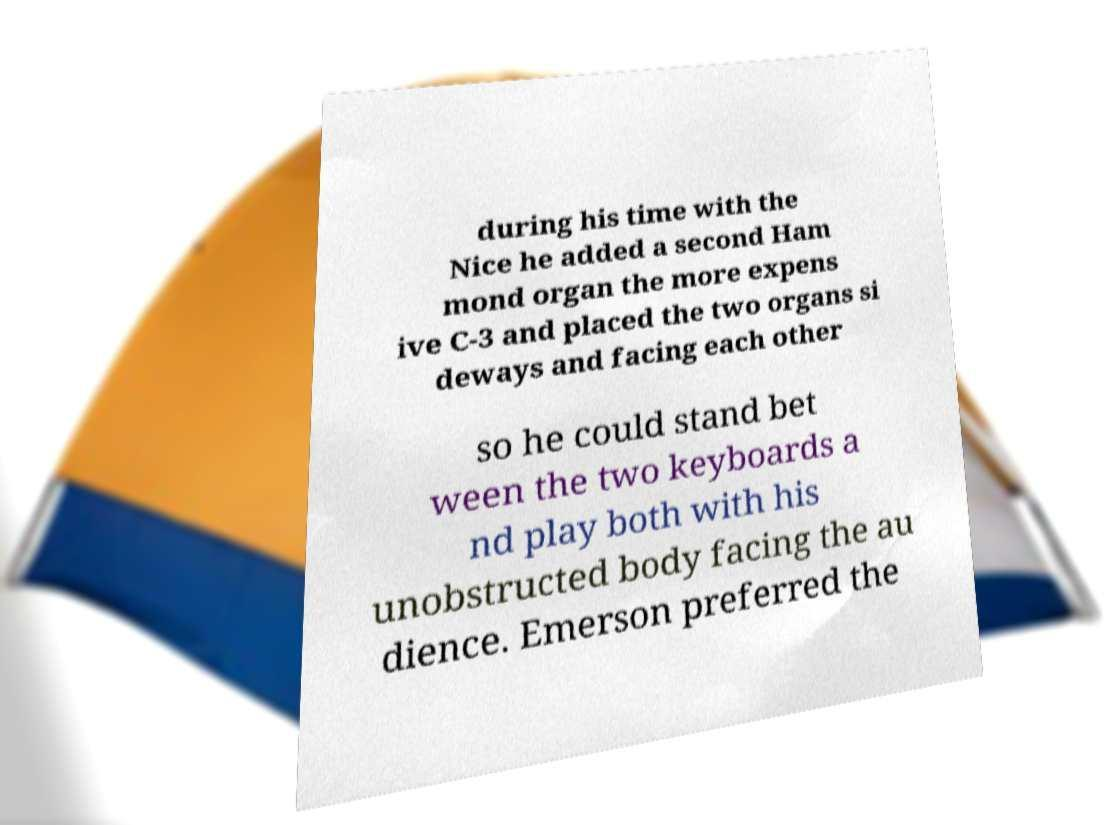Could you assist in decoding the text presented in this image and type it out clearly? during his time with the Nice he added a second Ham mond organ the more expens ive C-3 and placed the two organs si deways and facing each other so he could stand bet ween the two keyboards a nd play both with his unobstructed body facing the au dience. Emerson preferred the 